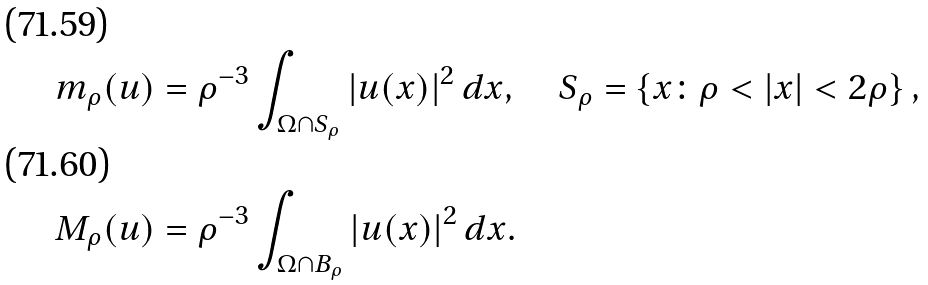Convert formula to latex. <formula><loc_0><loc_0><loc_500><loc_500>m _ { \rho } ( u ) & = \rho ^ { - 3 } \int _ { \Omega \cap S _ { \rho } } | u ( x ) | ^ { 2 } \, d x , \quad S _ { \rho } = \left \{ x \colon \rho < | x | < 2 \rho \right \} , \\ M _ { \rho } ( u ) & = \rho ^ { - 3 } \int _ { \Omega \cap B _ { \rho } } | u ( x ) | ^ { 2 } \, d x .</formula> 